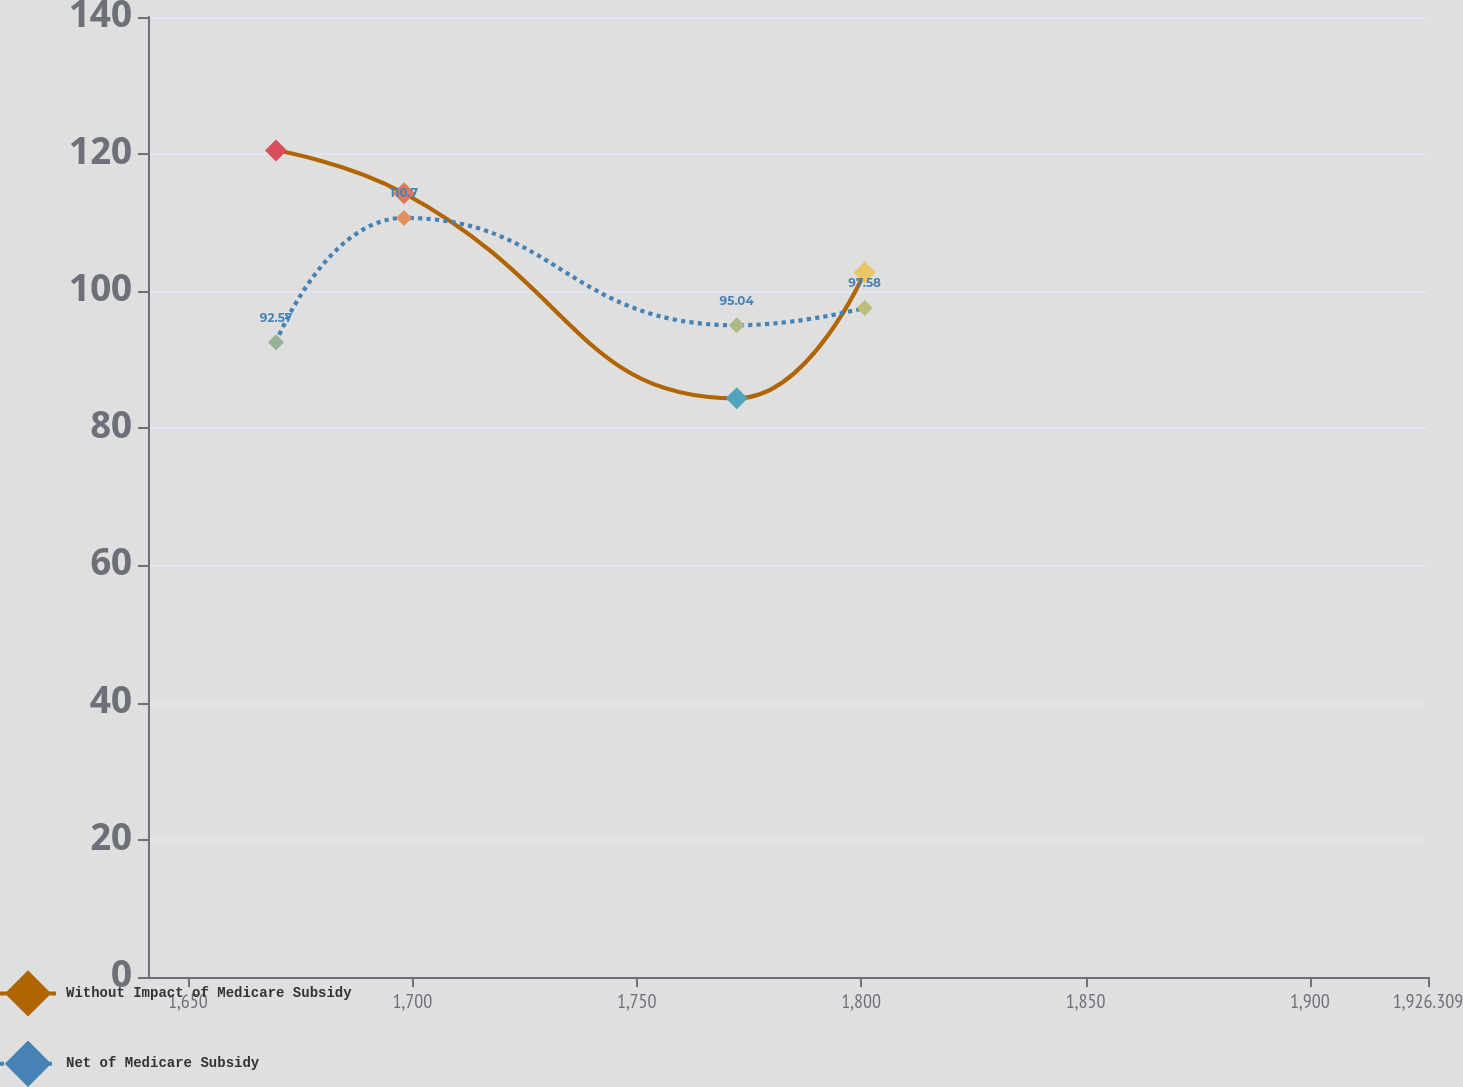Convert chart. <chart><loc_0><loc_0><loc_500><loc_500><line_chart><ecel><fcel>Without Impact of Medicare Subsidy<fcel>Net of Medicare Subsidy<nl><fcel>1669.62<fcel>120.53<fcel>92.57<nl><fcel>1698.14<fcel>114.3<fcel>110.7<nl><fcel>1772.27<fcel>84.39<fcel>95.04<nl><fcel>1800.79<fcel>102.74<fcel>97.58<nl><fcel>1954.83<fcel>88<fcel>86.01<nl></chart> 